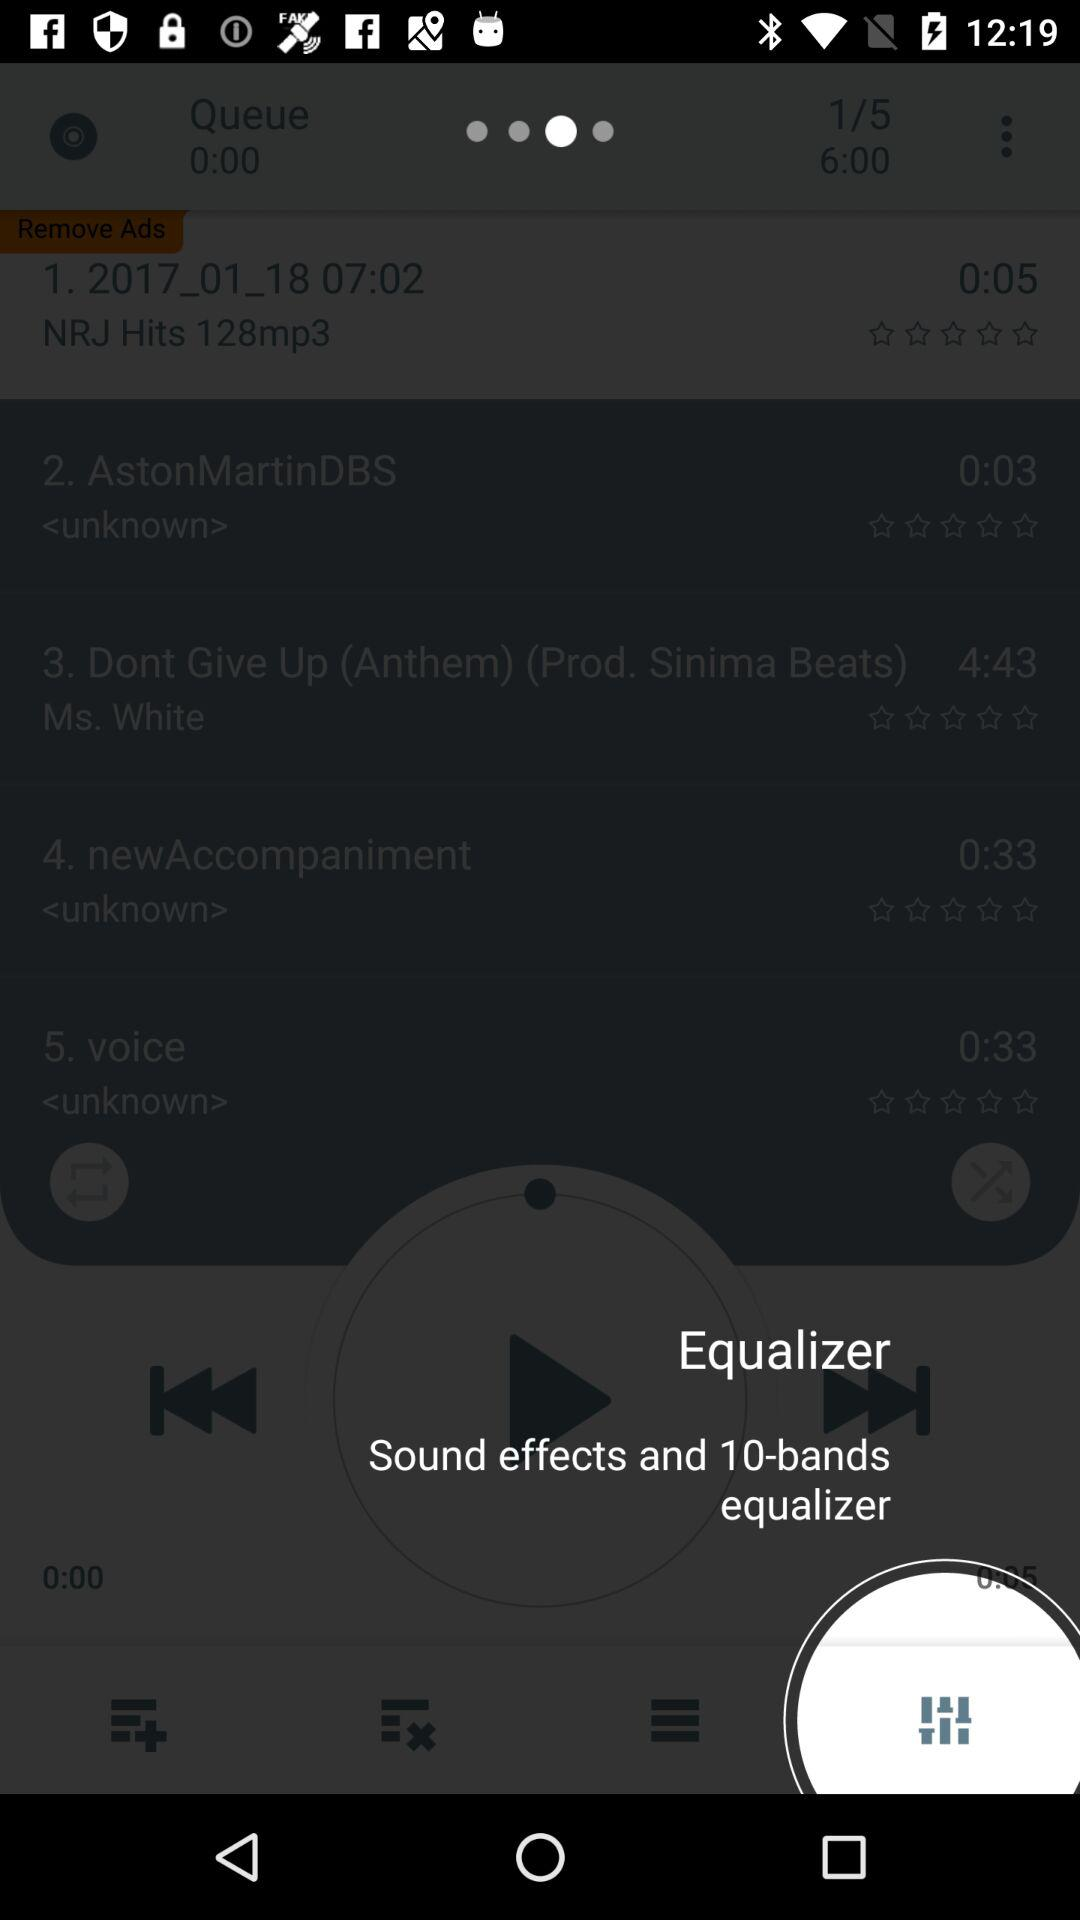How many songs are currently in the queue?
Answer the question using a single word or phrase. 5 